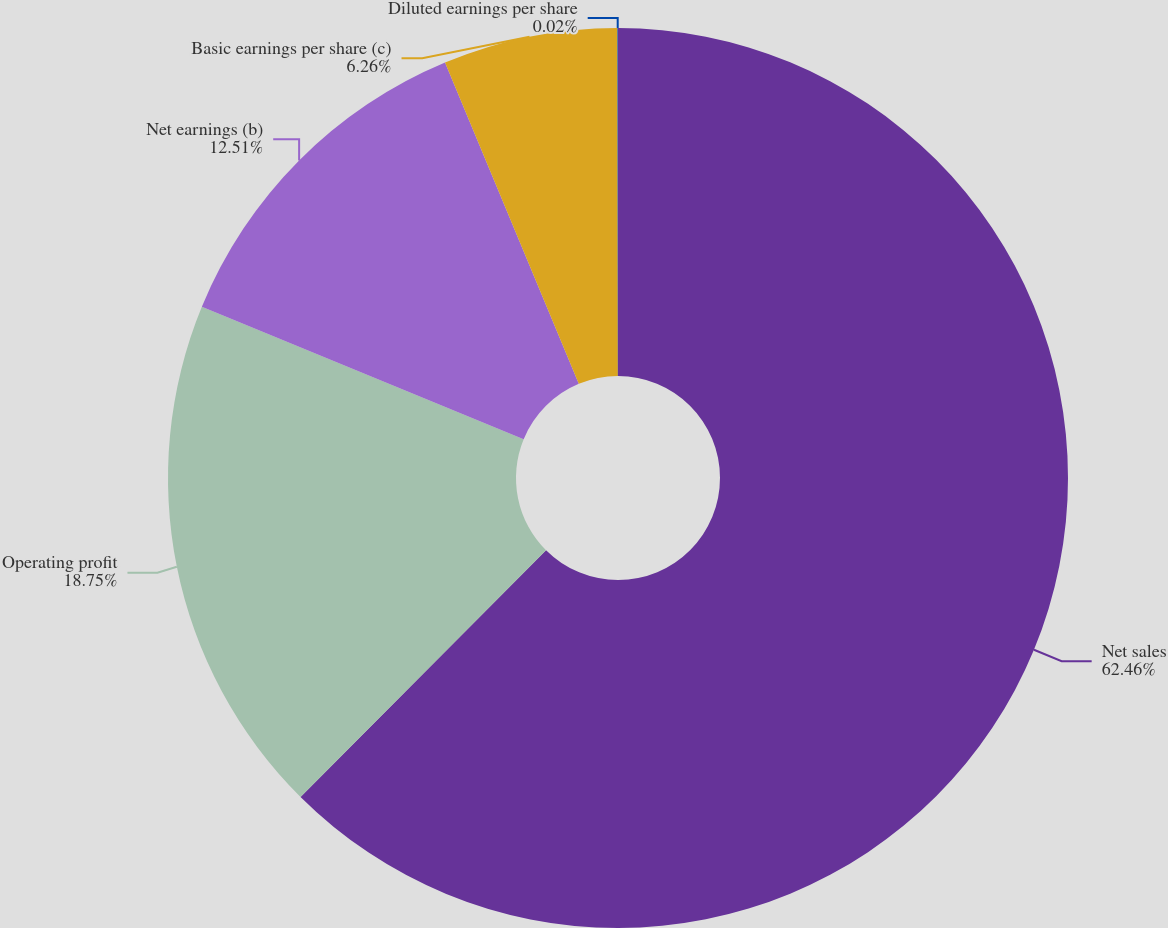Convert chart to OTSL. <chart><loc_0><loc_0><loc_500><loc_500><pie_chart><fcel>Net sales<fcel>Operating profit<fcel>Net earnings (b)<fcel>Basic earnings per share (c)<fcel>Diluted earnings per share<nl><fcel>62.47%<fcel>18.75%<fcel>12.51%<fcel>6.26%<fcel>0.02%<nl></chart> 